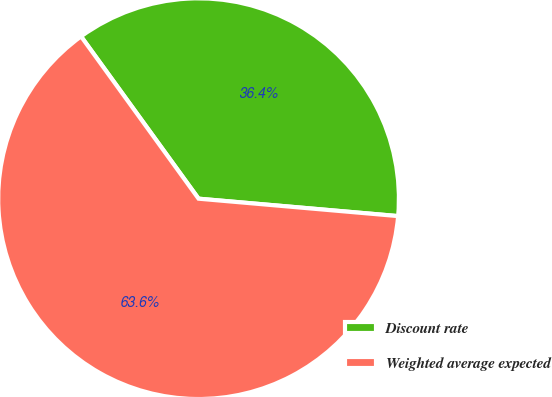Convert chart. <chart><loc_0><loc_0><loc_500><loc_500><pie_chart><fcel>Discount rate<fcel>Weighted average expected<nl><fcel>36.36%<fcel>63.64%<nl></chart> 